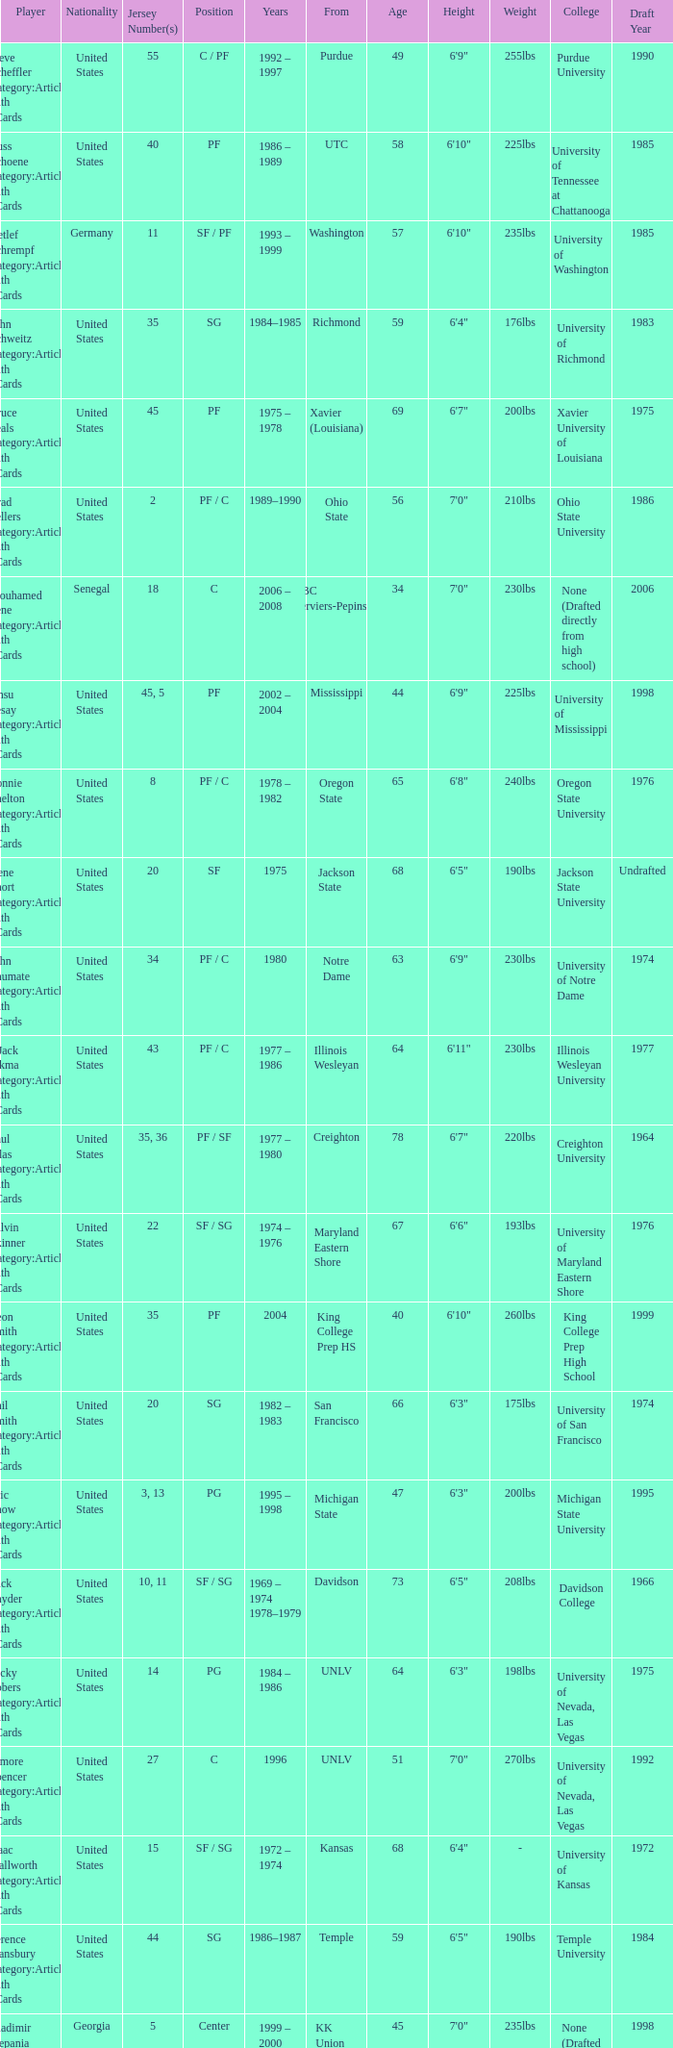What nationality is the player from Oregon State? United States. 